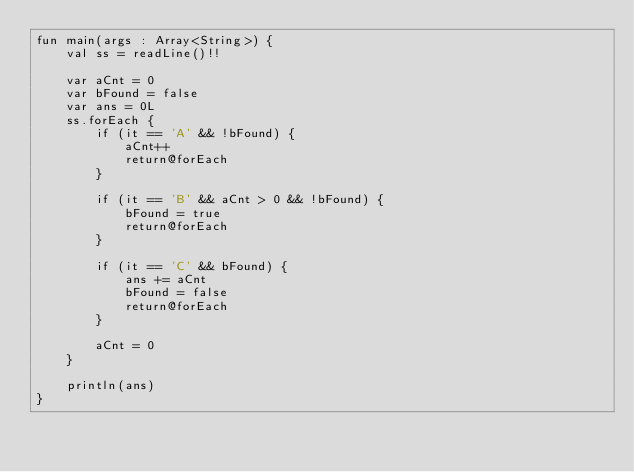<code> <loc_0><loc_0><loc_500><loc_500><_Kotlin_>fun main(args : Array<String>) {
    val ss = readLine()!!

    var aCnt = 0
    var bFound = false
    var ans = 0L
    ss.forEach {
        if (it == 'A' && !bFound) {
            aCnt++
            return@forEach
        }

        if (it == 'B' && aCnt > 0 && !bFound) {
            bFound = true
            return@forEach
        }

        if (it == 'C' && bFound) {
            ans += aCnt
            bFound = false
            return@forEach
        }

        aCnt = 0
    }

    println(ans)
}</code> 